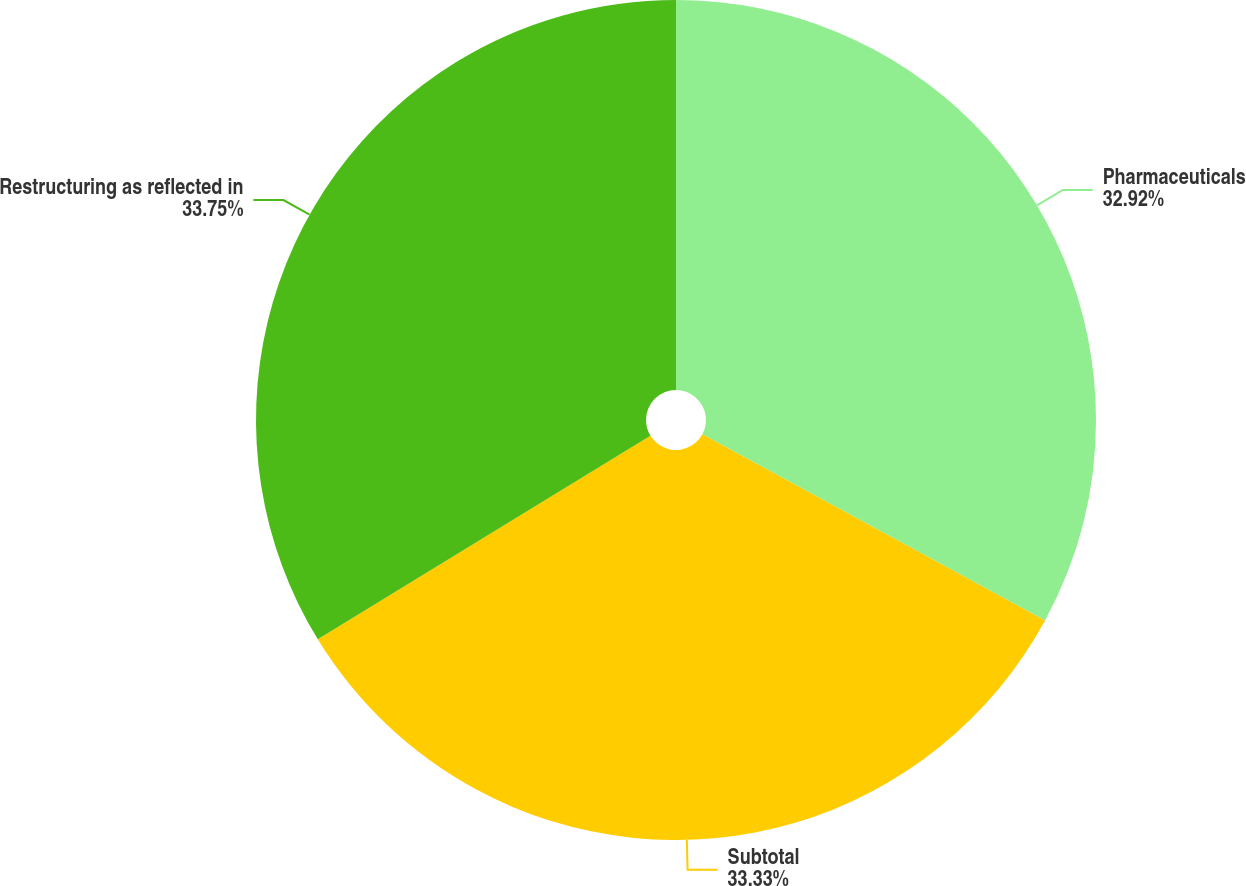Convert chart. <chart><loc_0><loc_0><loc_500><loc_500><pie_chart><fcel>Pharmaceuticals<fcel>Subtotal<fcel>Restructuring as reflected in<nl><fcel>32.92%<fcel>33.33%<fcel>33.74%<nl></chart> 